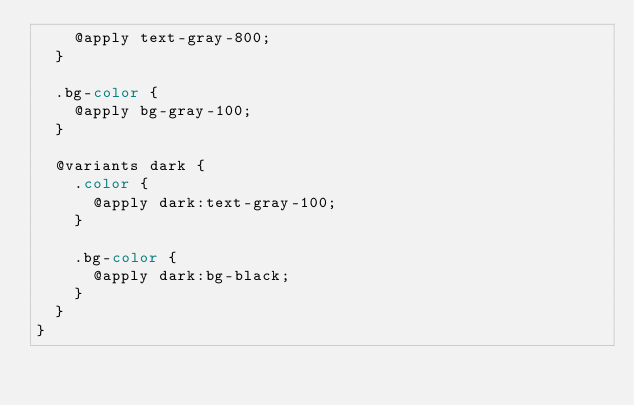Convert code to text. <code><loc_0><loc_0><loc_500><loc_500><_CSS_>    @apply text-gray-800;
  }

  .bg-color {
    @apply bg-gray-100;
  }

  @variants dark {
    .color {
      @apply dark:text-gray-100;
    }

    .bg-color {
      @apply dark:bg-black;
    }
  }
}
</code> 